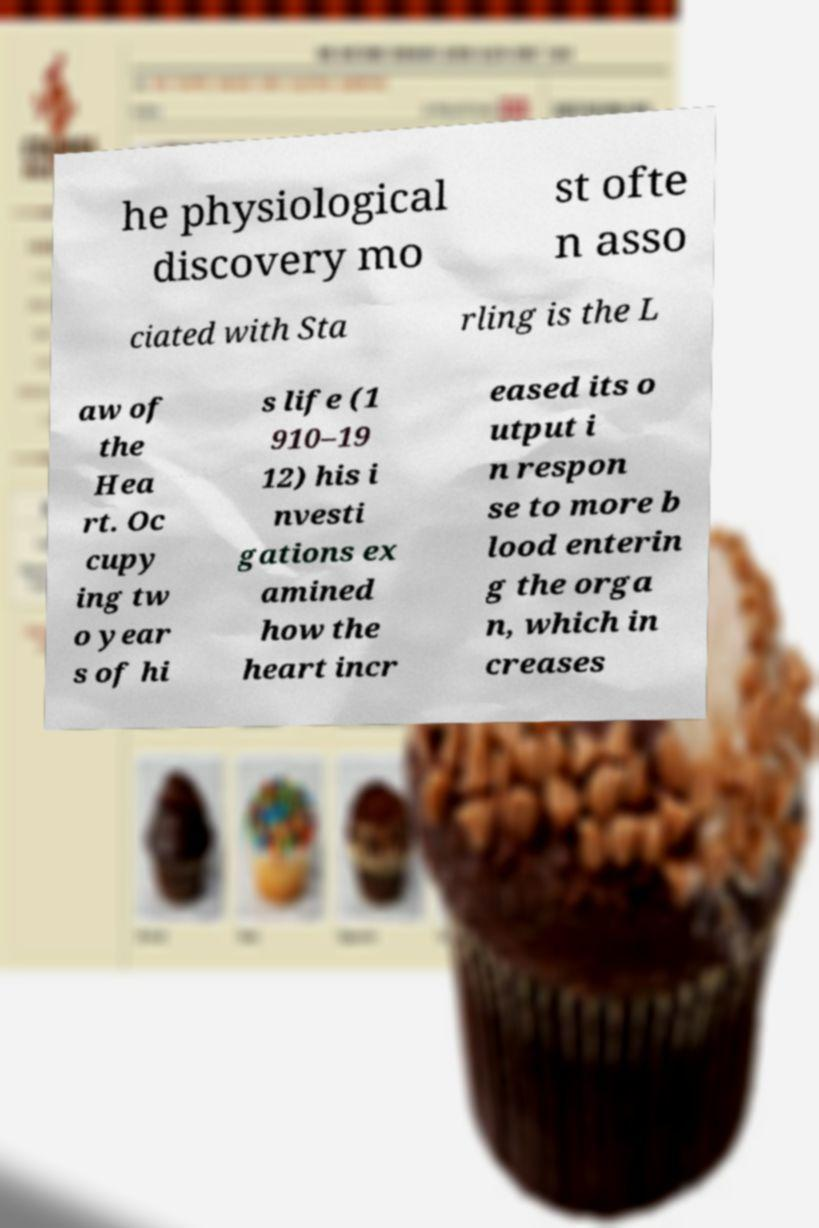Please read and relay the text visible in this image. What does it say? he physiological discovery mo st ofte n asso ciated with Sta rling is the L aw of the Hea rt. Oc cupy ing tw o year s of hi s life (1 910–19 12) his i nvesti gations ex amined how the heart incr eased its o utput i n respon se to more b lood enterin g the orga n, which in creases 